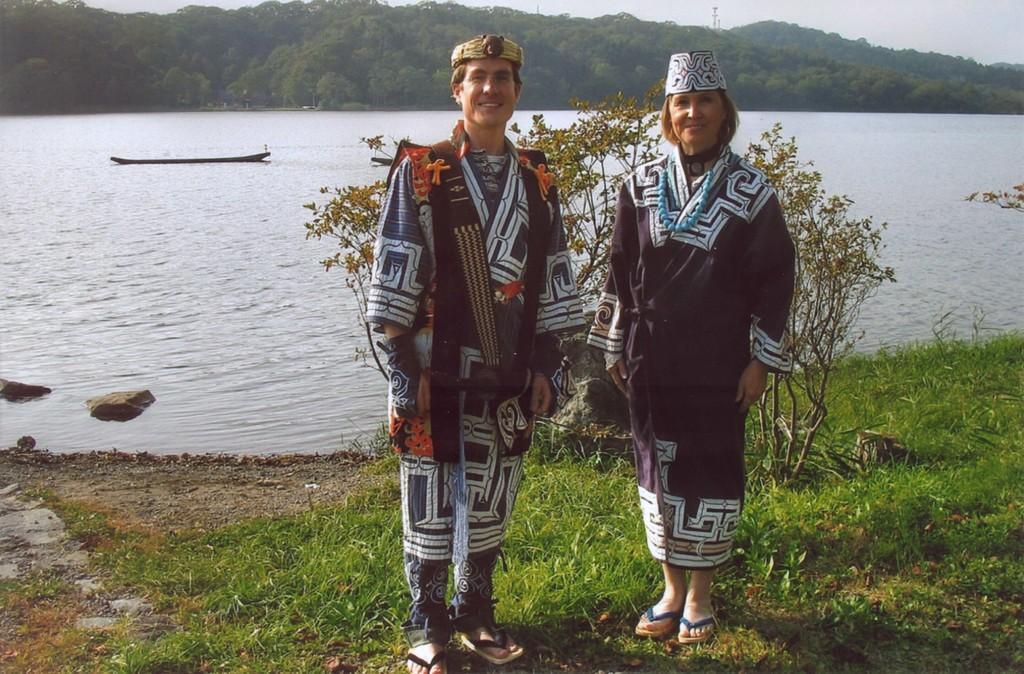How would you summarize this image in a sentence or two? In this picture, we see a man and a woman are standing. Both of them are smiling and they are posing for the photo. Behind them, we see the trees. At the bottom, we see the grass. In the middle, we see water and this water might be in the river. On the left side, we see the stones. There are trees and a tower in the background. At the top, we see the sky. 